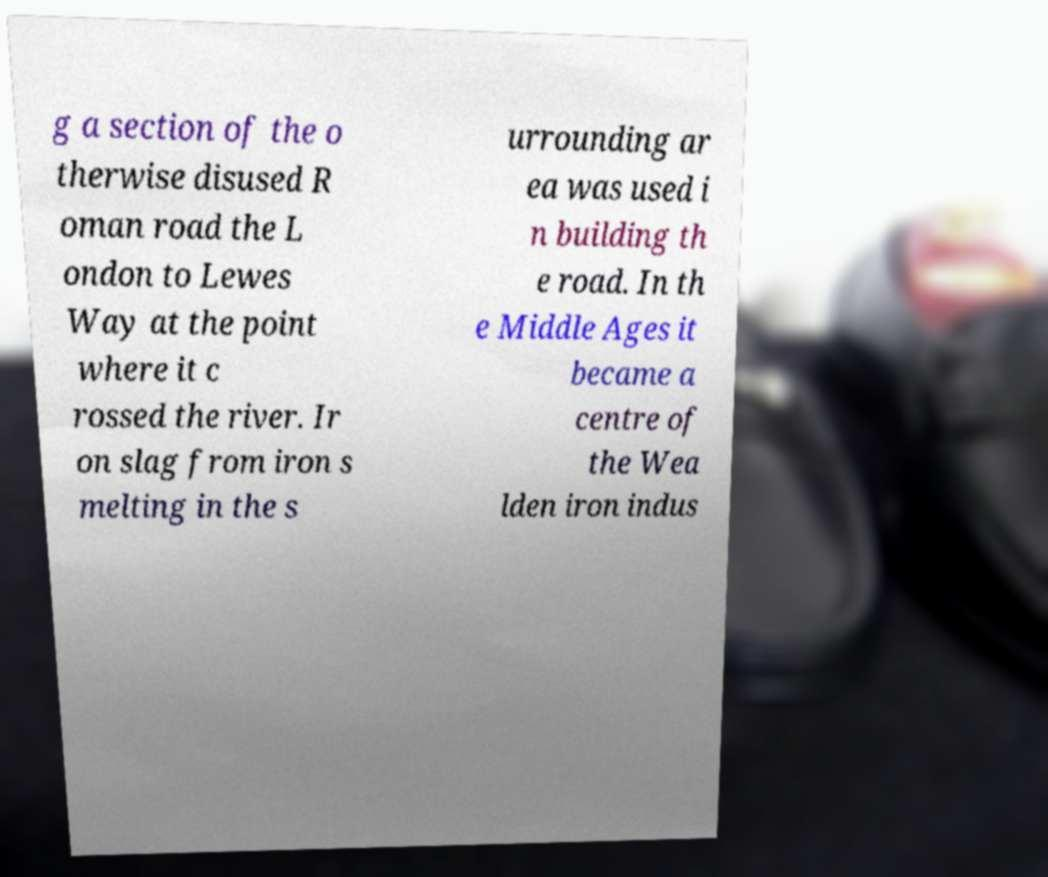Could you extract and type out the text from this image? g a section of the o therwise disused R oman road the L ondon to Lewes Way at the point where it c rossed the river. Ir on slag from iron s melting in the s urrounding ar ea was used i n building th e road. In th e Middle Ages it became a centre of the Wea lden iron indus 